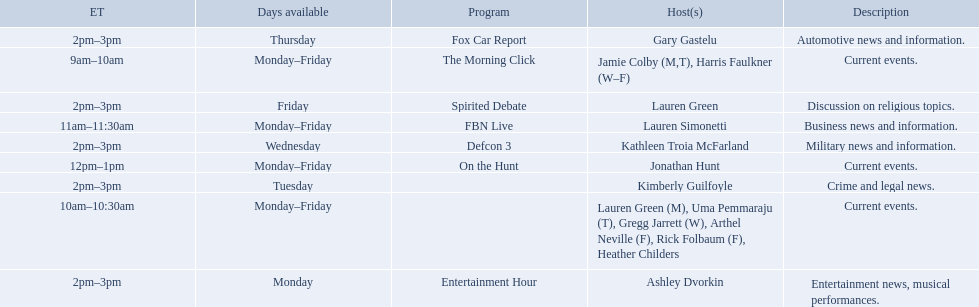Who are all of the hosts? Jamie Colby (M,T), Harris Faulkner (W–F), Lauren Green (M), Uma Pemmaraju (T), Gregg Jarrett (W), Arthel Neville (F), Rick Folbaum (F), Heather Childers, Lauren Simonetti, Jonathan Hunt, Ashley Dvorkin, Kimberly Guilfoyle, Kathleen Troia McFarland, Gary Gastelu, Lauren Green. Which hosts have shows on fridays? Jamie Colby (M,T), Harris Faulkner (W–F), Lauren Green (M), Uma Pemmaraju (T), Gregg Jarrett (W), Arthel Neville (F), Rick Folbaum (F), Heather Childers, Lauren Simonetti, Jonathan Hunt, Lauren Green. Of those, which host's show airs at 2pm? Lauren Green. 